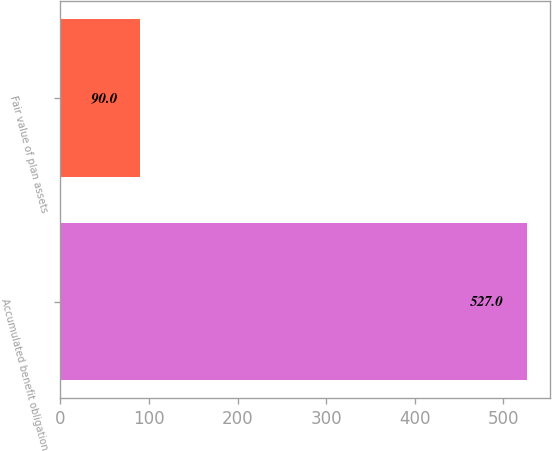Convert chart to OTSL. <chart><loc_0><loc_0><loc_500><loc_500><bar_chart><fcel>Accumulated benefit obligation<fcel>Fair value of plan assets<nl><fcel>527<fcel>90<nl></chart> 